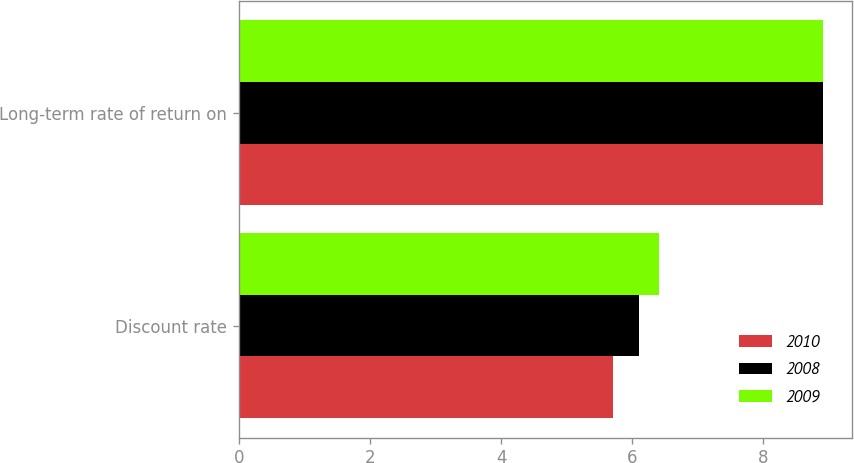<chart> <loc_0><loc_0><loc_500><loc_500><stacked_bar_chart><ecel><fcel>Discount rate<fcel>Long-term rate of return on<nl><fcel>2010<fcel>5.7<fcel>8.9<nl><fcel>2008<fcel>6.1<fcel>8.9<nl><fcel>2009<fcel>6.4<fcel>8.9<nl></chart> 